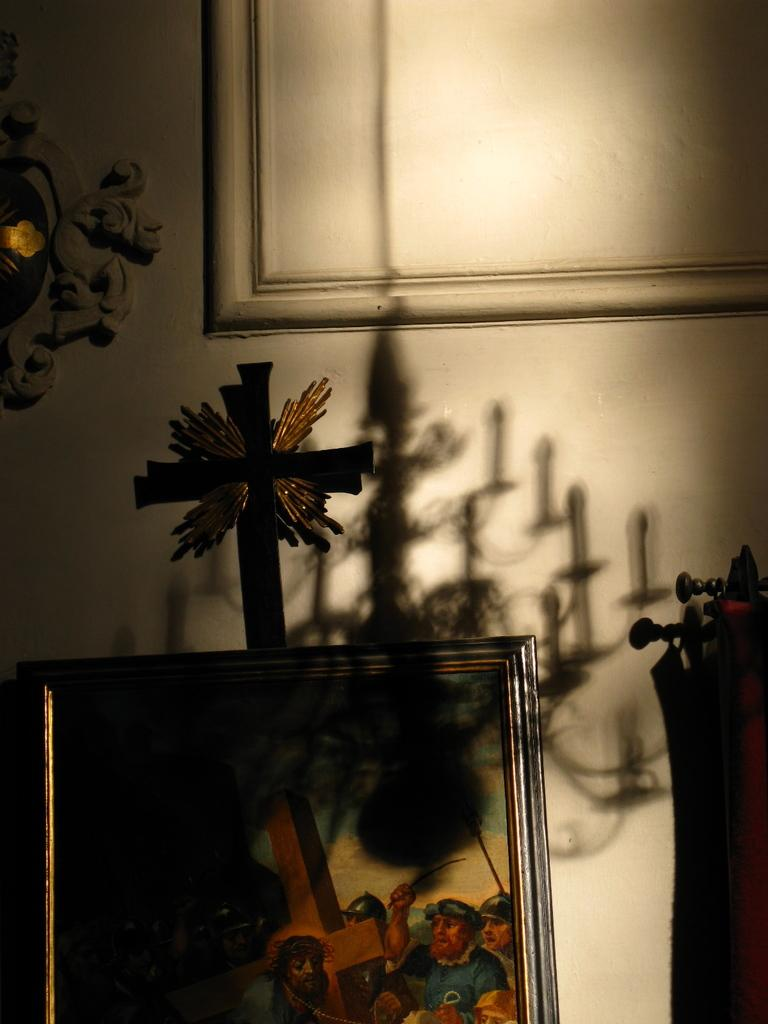What is the main object in the foreground of the image? There is a photo frame in the image. What else can be seen in the image besides the photo frame? There are other objects in the image. What is present on the wall in the background of the image? There is a frame on the wall in the background of the image, and there is a shadow of a chandelier on the wall as well. How many fairies are dancing around the photo frame in the image? There are no fairies present in the image. Are there any girls interacting with the photo frame in the image? The provided facts do not mention any girls interacting with the photo frame in the image. 